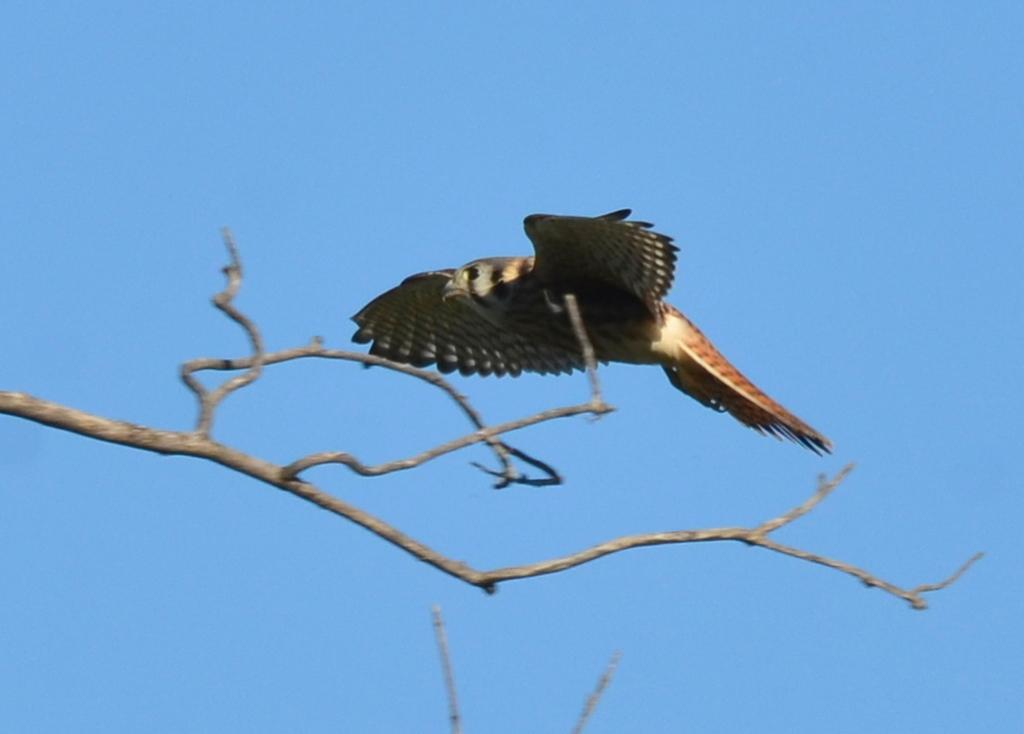What type of animal is in the image? There is a bird in the image. Where is the bird located in the image? The bird is on a branch in the image. In which area of the image is the bird situated? The bird is in the foreground area of the image. What can be seen in the background of the image? The sky is visible in the background of the image. What type of bubble can be seen surrounding the bird in the image? There is no bubble present in the image; the bird is on a branch. 